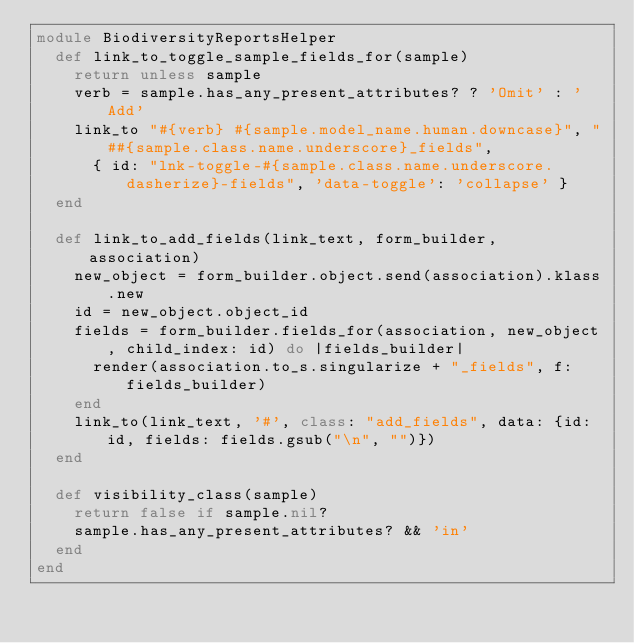<code> <loc_0><loc_0><loc_500><loc_500><_Ruby_>module BiodiversityReportsHelper
  def link_to_toggle_sample_fields_for(sample)
    return unless sample
    verb = sample.has_any_present_attributes? ? 'Omit' : 'Add'
    link_to "#{verb} #{sample.model_name.human.downcase}", "##{sample.class.name.underscore}_fields",
      { id: "lnk-toggle-#{sample.class.name.underscore.dasherize}-fields", 'data-toggle': 'collapse' }
  end

  def link_to_add_fields(link_text, form_builder, association)
    new_object = form_builder.object.send(association).klass.new
    id = new_object.object_id
    fields = form_builder.fields_for(association, new_object, child_index: id) do |fields_builder|
      render(association.to_s.singularize + "_fields", f: fields_builder)
    end
    link_to(link_text, '#', class: "add_fields", data: {id: id, fields: fields.gsub("\n", "")})
  end

  def visibility_class(sample)
    return false if sample.nil?
    sample.has_any_present_attributes? && 'in'
  end
end
</code> 